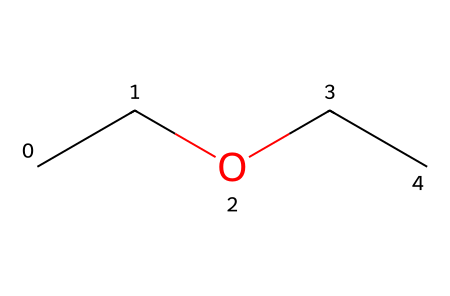What is the name of the chemical represented by this structure? The structure with the SMILES representation "CCOCC" corresponds to diethyl ether, which is commonly used as an anesthetic.
Answer: diethyl ether How many carbon atoms are in diethyl ether? The SMILES notation "CCOCC" indicates there are two ethyl groups (each containing two carbon atoms), resulting in a total of four carbon atoms.
Answer: four What type of functional group is present in diethyl ether? The structure reveals that diethyl ether contains an ether functional group characterized by an oxygen atom bonded to two carbon chains.
Answer: ether How many hydrogen atoms are connected to the carbon atoms in diethyl ether? Each ethyl group contributes five hydrogen atoms (4 from the terminal carbon and 1 from the middle carbon), totaling ten hydrogen atoms in diethyl ether.
Answer: ten What is the bond type between the carbon and oxygen in diethyl ether? The bond between the carbon atoms and the oxygen in diethyl ether is a single covalent bond, which is common for ethers.
Answer: single covalent What is the main use of diethyl ether in medicine? Diethyl ether is primarily used in medicine as a general anesthetic due to its ability to induce unconsciousness and diminish sensation.
Answer: anesthetic How many oxygen atoms are in the chemical structure of diethyl ether? The SMILES "CCOCC" indicates there is only one oxygen atom present in the structure of diethyl ether.
Answer: one 